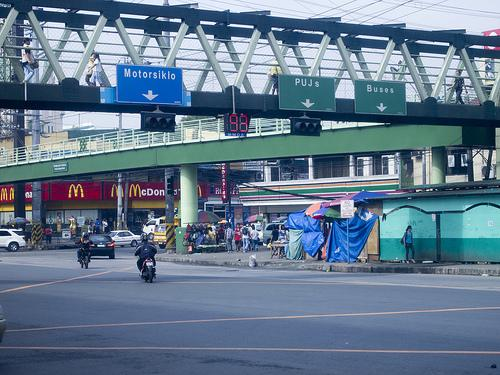Count the number of visible streets in the image. There are a total of 12 visible streets in the image. Analyze the sentiment evoked by the image by mentioning the predominant activity taking place. The image captures an everyday, lively city scene with people walking and riding motorcycles on a busy street, evoking a sense of urban hustle and bustle. 